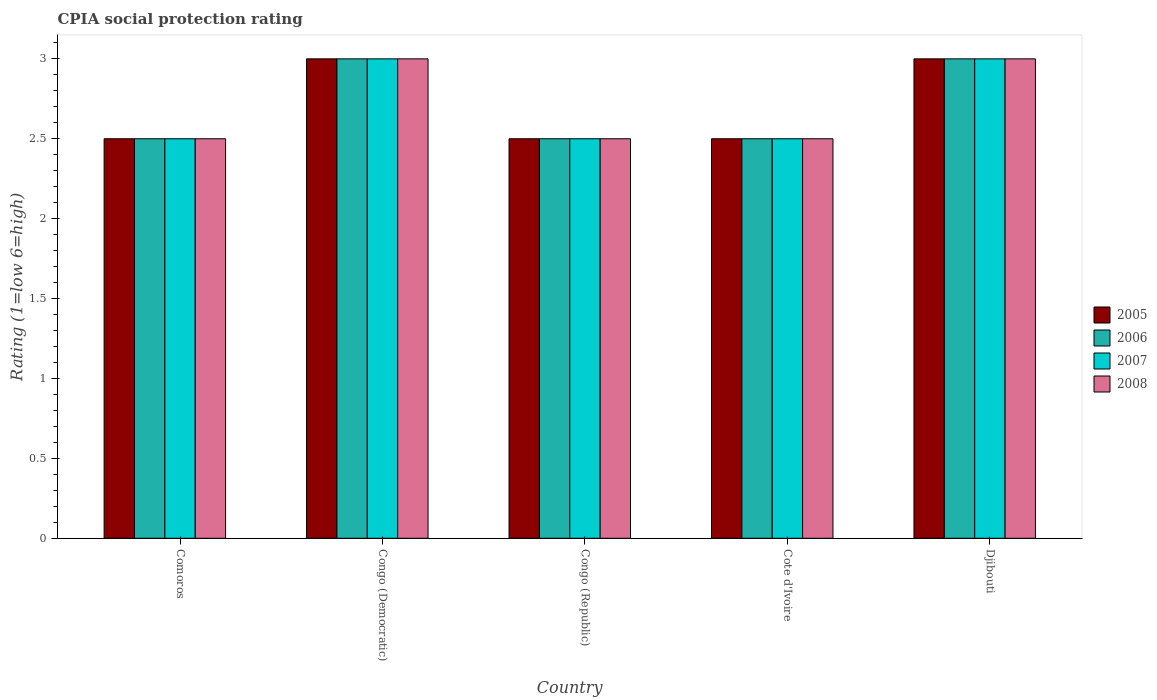How many different coloured bars are there?
Provide a short and direct response. 4. Are the number of bars per tick equal to the number of legend labels?
Make the answer very short. Yes. How many bars are there on the 5th tick from the right?
Provide a short and direct response. 4. What is the label of the 3rd group of bars from the left?
Your answer should be compact. Congo (Republic). In how many cases, is the number of bars for a given country not equal to the number of legend labels?
Your answer should be very brief. 0. In which country was the CPIA rating in 2007 maximum?
Keep it short and to the point. Congo (Democratic). In which country was the CPIA rating in 2008 minimum?
Give a very brief answer. Comoros. What is the difference between the CPIA rating in 2007 in Congo (Democratic) and that in Djibouti?
Give a very brief answer. 0. In how many countries, is the CPIA rating in 2005 greater than 0.4?
Give a very brief answer. 5. What is the ratio of the CPIA rating in 2007 in Comoros to that in Congo (Republic)?
Your answer should be compact. 1. What is the difference between the highest and the second highest CPIA rating in 2005?
Give a very brief answer. -0.5. What is the difference between the highest and the lowest CPIA rating in 2005?
Make the answer very short. 0.5. In how many countries, is the CPIA rating in 2005 greater than the average CPIA rating in 2005 taken over all countries?
Give a very brief answer. 2. What does the 2nd bar from the right in Djibouti represents?
Provide a short and direct response. 2007. Are all the bars in the graph horizontal?
Provide a short and direct response. No. What is the difference between two consecutive major ticks on the Y-axis?
Offer a very short reply. 0.5. Are the values on the major ticks of Y-axis written in scientific E-notation?
Provide a succinct answer. No. Does the graph contain grids?
Ensure brevity in your answer.  No. How many legend labels are there?
Keep it short and to the point. 4. How are the legend labels stacked?
Offer a very short reply. Vertical. What is the title of the graph?
Make the answer very short. CPIA social protection rating. Does "1972" appear as one of the legend labels in the graph?
Provide a short and direct response. No. What is the label or title of the X-axis?
Give a very brief answer. Country. What is the label or title of the Y-axis?
Provide a short and direct response. Rating (1=low 6=high). What is the Rating (1=low 6=high) in 2005 in Congo (Democratic)?
Give a very brief answer. 3. What is the Rating (1=low 6=high) of 2007 in Congo (Democratic)?
Your answer should be compact. 3. What is the Rating (1=low 6=high) in 2008 in Congo (Democratic)?
Provide a succinct answer. 3. What is the Rating (1=low 6=high) in 2007 in Congo (Republic)?
Offer a terse response. 2.5. What is the Rating (1=low 6=high) of 2008 in Congo (Republic)?
Keep it short and to the point. 2.5. What is the Rating (1=low 6=high) in 2006 in Cote d'Ivoire?
Your answer should be compact. 2.5. What is the Rating (1=low 6=high) in 2007 in Cote d'Ivoire?
Your response must be concise. 2.5. What is the Rating (1=low 6=high) of 2005 in Djibouti?
Keep it short and to the point. 3. What is the Rating (1=low 6=high) of 2007 in Djibouti?
Your answer should be compact. 3. What is the Rating (1=low 6=high) in 2008 in Djibouti?
Offer a very short reply. 3. Across all countries, what is the maximum Rating (1=low 6=high) in 2007?
Offer a very short reply. 3. Across all countries, what is the maximum Rating (1=low 6=high) of 2008?
Offer a terse response. 3. Across all countries, what is the minimum Rating (1=low 6=high) in 2005?
Provide a short and direct response. 2.5. What is the total Rating (1=low 6=high) in 2005 in the graph?
Provide a short and direct response. 13.5. What is the total Rating (1=low 6=high) of 2006 in the graph?
Ensure brevity in your answer.  13.5. What is the total Rating (1=low 6=high) of 2008 in the graph?
Give a very brief answer. 13.5. What is the difference between the Rating (1=low 6=high) of 2006 in Comoros and that in Congo (Democratic)?
Your answer should be very brief. -0.5. What is the difference between the Rating (1=low 6=high) of 2006 in Comoros and that in Congo (Republic)?
Keep it short and to the point. 0. What is the difference between the Rating (1=low 6=high) in 2005 in Comoros and that in Cote d'Ivoire?
Offer a very short reply. 0. What is the difference between the Rating (1=low 6=high) in 2007 in Comoros and that in Cote d'Ivoire?
Give a very brief answer. 0. What is the difference between the Rating (1=low 6=high) in 2008 in Comoros and that in Cote d'Ivoire?
Ensure brevity in your answer.  0. What is the difference between the Rating (1=low 6=high) of 2006 in Comoros and that in Djibouti?
Your answer should be very brief. -0.5. What is the difference between the Rating (1=low 6=high) of 2007 in Comoros and that in Djibouti?
Your answer should be compact. -0.5. What is the difference between the Rating (1=low 6=high) of 2005 in Congo (Democratic) and that in Cote d'Ivoire?
Provide a succinct answer. 0.5. What is the difference between the Rating (1=low 6=high) of 2007 in Congo (Democratic) and that in Cote d'Ivoire?
Keep it short and to the point. 0.5. What is the difference between the Rating (1=low 6=high) of 2005 in Congo (Democratic) and that in Djibouti?
Keep it short and to the point. 0. What is the difference between the Rating (1=low 6=high) in 2006 in Congo (Democratic) and that in Djibouti?
Provide a short and direct response. 0. What is the difference between the Rating (1=low 6=high) of 2008 in Congo (Democratic) and that in Djibouti?
Ensure brevity in your answer.  0. What is the difference between the Rating (1=low 6=high) of 2007 in Congo (Republic) and that in Cote d'Ivoire?
Give a very brief answer. 0. What is the difference between the Rating (1=low 6=high) in 2008 in Congo (Republic) and that in Cote d'Ivoire?
Provide a succinct answer. 0. What is the difference between the Rating (1=low 6=high) in 2006 in Congo (Republic) and that in Djibouti?
Your response must be concise. -0.5. What is the difference between the Rating (1=low 6=high) in 2005 in Cote d'Ivoire and that in Djibouti?
Provide a succinct answer. -0.5. What is the difference between the Rating (1=low 6=high) of 2007 in Cote d'Ivoire and that in Djibouti?
Offer a very short reply. -0.5. What is the difference between the Rating (1=low 6=high) in 2005 in Comoros and the Rating (1=low 6=high) in 2007 in Congo (Democratic)?
Offer a terse response. -0.5. What is the difference between the Rating (1=low 6=high) in 2006 in Comoros and the Rating (1=low 6=high) in 2008 in Congo (Democratic)?
Your answer should be very brief. -0.5. What is the difference between the Rating (1=low 6=high) of 2007 in Comoros and the Rating (1=low 6=high) of 2008 in Congo (Democratic)?
Provide a succinct answer. -0.5. What is the difference between the Rating (1=low 6=high) of 2005 in Comoros and the Rating (1=low 6=high) of 2007 in Cote d'Ivoire?
Provide a short and direct response. 0. What is the difference between the Rating (1=low 6=high) of 2005 in Comoros and the Rating (1=low 6=high) of 2008 in Cote d'Ivoire?
Keep it short and to the point. 0. What is the difference between the Rating (1=low 6=high) of 2006 in Comoros and the Rating (1=low 6=high) of 2008 in Cote d'Ivoire?
Ensure brevity in your answer.  0. What is the difference between the Rating (1=low 6=high) of 2005 in Comoros and the Rating (1=low 6=high) of 2007 in Djibouti?
Your answer should be very brief. -0.5. What is the difference between the Rating (1=low 6=high) of 2005 in Comoros and the Rating (1=low 6=high) of 2008 in Djibouti?
Your answer should be compact. -0.5. What is the difference between the Rating (1=low 6=high) in 2006 in Comoros and the Rating (1=low 6=high) in 2007 in Djibouti?
Offer a very short reply. -0.5. What is the difference between the Rating (1=low 6=high) in 2006 in Comoros and the Rating (1=low 6=high) in 2008 in Djibouti?
Offer a very short reply. -0.5. What is the difference between the Rating (1=low 6=high) in 2007 in Comoros and the Rating (1=low 6=high) in 2008 in Djibouti?
Your answer should be compact. -0.5. What is the difference between the Rating (1=low 6=high) of 2005 in Congo (Democratic) and the Rating (1=low 6=high) of 2007 in Congo (Republic)?
Ensure brevity in your answer.  0.5. What is the difference between the Rating (1=low 6=high) in 2005 in Congo (Democratic) and the Rating (1=low 6=high) in 2008 in Congo (Republic)?
Your answer should be very brief. 0.5. What is the difference between the Rating (1=low 6=high) in 2006 in Congo (Democratic) and the Rating (1=low 6=high) in 2007 in Congo (Republic)?
Your response must be concise. 0.5. What is the difference between the Rating (1=low 6=high) in 2007 in Congo (Democratic) and the Rating (1=low 6=high) in 2008 in Congo (Republic)?
Provide a succinct answer. 0.5. What is the difference between the Rating (1=low 6=high) in 2005 in Congo (Democratic) and the Rating (1=low 6=high) in 2007 in Cote d'Ivoire?
Give a very brief answer. 0.5. What is the difference between the Rating (1=low 6=high) of 2005 in Congo (Democratic) and the Rating (1=low 6=high) of 2008 in Cote d'Ivoire?
Your response must be concise. 0.5. What is the difference between the Rating (1=low 6=high) of 2007 in Congo (Democratic) and the Rating (1=low 6=high) of 2008 in Cote d'Ivoire?
Make the answer very short. 0.5. What is the difference between the Rating (1=low 6=high) of 2005 in Congo (Democratic) and the Rating (1=low 6=high) of 2006 in Djibouti?
Offer a very short reply. 0. What is the difference between the Rating (1=low 6=high) of 2005 in Congo (Democratic) and the Rating (1=low 6=high) of 2008 in Djibouti?
Ensure brevity in your answer.  0. What is the difference between the Rating (1=low 6=high) of 2006 in Congo (Democratic) and the Rating (1=low 6=high) of 2007 in Djibouti?
Offer a very short reply. 0. What is the difference between the Rating (1=low 6=high) of 2007 in Congo (Democratic) and the Rating (1=low 6=high) of 2008 in Djibouti?
Your answer should be compact. 0. What is the difference between the Rating (1=low 6=high) of 2005 in Congo (Republic) and the Rating (1=low 6=high) of 2006 in Cote d'Ivoire?
Provide a short and direct response. 0. What is the difference between the Rating (1=low 6=high) in 2005 in Congo (Republic) and the Rating (1=low 6=high) in 2007 in Cote d'Ivoire?
Your response must be concise. 0. What is the difference between the Rating (1=low 6=high) in 2007 in Congo (Republic) and the Rating (1=low 6=high) in 2008 in Cote d'Ivoire?
Your answer should be very brief. 0. What is the difference between the Rating (1=low 6=high) in 2005 in Congo (Republic) and the Rating (1=low 6=high) in 2008 in Djibouti?
Provide a short and direct response. -0.5. What is the difference between the Rating (1=low 6=high) of 2006 in Congo (Republic) and the Rating (1=low 6=high) of 2008 in Djibouti?
Provide a succinct answer. -0.5. What is the difference between the Rating (1=low 6=high) of 2005 in Cote d'Ivoire and the Rating (1=low 6=high) of 2006 in Djibouti?
Keep it short and to the point. -0.5. What is the difference between the Rating (1=low 6=high) in 2005 in Cote d'Ivoire and the Rating (1=low 6=high) in 2007 in Djibouti?
Give a very brief answer. -0.5. What is the difference between the Rating (1=low 6=high) of 2006 in Cote d'Ivoire and the Rating (1=low 6=high) of 2007 in Djibouti?
Give a very brief answer. -0.5. What is the difference between the Rating (1=low 6=high) of 2007 in Cote d'Ivoire and the Rating (1=low 6=high) of 2008 in Djibouti?
Keep it short and to the point. -0.5. What is the average Rating (1=low 6=high) in 2005 per country?
Offer a very short reply. 2.7. What is the average Rating (1=low 6=high) in 2007 per country?
Make the answer very short. 2.7. What is the difference between the Rating (1=low 6=high) in 2005 and Rating (1=low 6=high) in 2006 in Comoros?
Offer a very short reply. 0. What is the difference between the Rating (1=low 6=high) of 2005 and Rating (1=low 6=high) of 2007 in Comoros?
Offer a terse response. 0. What is the difference between the Rating (1=low 6=high) of 2006 and Rating (1=low 6=high) of 2007 in Comoros?
Provide a succinct answer. 0. What is the difference between the Rating (1=low 6=high) in 2006 and Rating (1=low 6=high) in 2008 in Comoros?
Provide a succinct answer. 0. What is the difference between the Rating (1=low 6=high) of 2005 and Rating (1=low 6=high) of 2008 in Congo (Democratic)?
Provide a short and direct response. 0. What is the difference between the Rating (1=low 6=high) in 2007 and Rating (1=low 6=high) in 2008 in Congo (Democratic)?
Your answer should be very brief. 0. What is the difference between the Rating (1=low 6=high) in 2005 and Rating (1=low 6=high) in 2007 in Cote d'Ivoire?
Offer a terse response. 0. What is the difference between the Rating (1=low 6=high) of 2005 and Rating (1=low 6=high) of 2008 in Cote d'Ivoire?
Offer a very short reply. 0. What is the difference between the Rating (1=low 6=high) in 2007 and Rating (1=low 6=high) in 2008 in Cote d'Ivoire?
Provide a short and direct response. 0. What is the difference between the Rating (1=low 6=high) of 2005 and Rating (1=low 6=high) of 2006 in Djibouti?
Your answer should be very brief. 0. What is the difference between the Rating (1=low 6=high) of 2006 and Rating (1=low 6=high) of 2007 in Djibouti?
Your response must be concise. 0. What is the difference between the Rating (1=low 6=high) of 2007 and Rating (1=low 6=high) of 2008 in Djibouti?
Your answer should be compact. 0. What is the ratio of the Rating (1=low 6=high) of 2005 in Comoros to that in Congo (Democratic)?
Provide a short and direct response. 0.83. What is the ratio of the Rating (1=low 6=high) of 2007 in Comoros to that in Congo (Democratic)?
Provide a succinct answer. 0.83. What is the ratio of the Rating (1=low 6=high) in 2005 in Comoros to that in Congo (Republic)?
Give a very brief answer. 1. What is the ratio of the Rating (1=low 6=high) of 2007 in Comoros to that in Congo (Republic)?
Provide a succinct answer. 1. What is the ratio of the Rating (1=low 6=high) in 2006 in Comoros to that in Cote d'Ivoire?
Offer a very short reply. 1. What is the ratio of the Rating (1=low 6=high) of 2007 in Comoros to that in Cote d'Ivoire?
Your answer should be very brief. 1. What is the ratio of the Rating (1=low 6=high) in 2008 in Comoros to that in Cote d'Ivoire?
Make the answer very short. 1. What is the ratio of the Rating (1=low 6=high) in 2007 in Comoros to that in Djibouti?
Give a very brief answer. 0.83. What is the ratio of the Rating (1=low 6=high) in 2005 in Congo (Democratic) to that in Cote d'Ivoire?
Your answer should be compact. 1.2. What is the ratio of the Rating (1=low 6=high) in 2006 in Congo (Democratic) to that in Cote d'Ivoire?
Offer a very short reply. 1.2. What is the ratio of the Rating (1=low 6=high) in 2007 in Congo (Democratic) to that in Cote d'Ivoire?
Your answer should be very brief. 1.2. What is the ratio of the Rating (1=low 6=high) of 2006 in Congo (Democratic) to that in Djibouti?
Offer a terse response. 1. What is the ratio of the Rating (1=low 6=high) of 2007 in Congo (Democratic) to that in Djibouti?
Provide a succinct answer. 1. What is the ratio of the Rating (1=low 6=high) in 2008 in Congo (Democratic) to that in Djibouti?
Provide a succinct answer. 1. What is the ratio of the Rating (1=low 6=high) in 2005 in Congo (Republic) to that in Cote d'Ivoire?
Provide a succinct answer. 1. What is the ratio of the Rating (1=low 6=high) of 2006 in Congo (Republic) to that in Cote d'Ivoire?
Offer a very short reply. 1. What is the ratio of the Rating (1=low 6=high) in 2007 in Congo (Republic) to that in Cote d'Ivoire?
Offer a very short reply. 1. What is the ratio of the Rating (1=low 6=high) of 2008 in Congo (Republic) to that in Cote d'Ivoire?
Keep it short and to the point. 1. What is the ratio of the Rating (1=low 6=high) in 2006 in Congo (Republic) to that in Djibouti?
Give a very brief answer. 0.83. What is the ratio of the Rating (1=low 6=high) in 2005 in Cote d'Ivoire to that in Djibouti?
Keep it short and to the point. 0.83. What is the ratio of the Rating (1=low 6=high) of 2008 in Cote d'Ivoire to that in Djibouti?
Offer a terse response. 0.83. What is the difference between the highest and the second highest Rating (1=low 6=high) in 2005?
Provide a succinct answer. 0. What is the difference between the highest and the second highest Rating (1=low 6=high) in 2006?
Provide a succinct answer. 0. What is the difference between the highest and the second highest Rating (1=low 6=high) of 2008?
Provide a short and direct response. 0. What is the difference between the highest and the lowest Rating (1=low 6=high) of 2005?
Provide a succinct answer. 0.5. What is the difference between the highest and the lowest Rating (1=low 6=high) in 2006?
Your response must be concise. 0.5. What is the difference between the highest and the lowest Rating (1=low 6=high) of 2007?
Keep it short and to the point. 0.5. What is the difference between the highest and the lowest Rating (1=low 6=high) in 2008?
Provide a short and direct response. 0.5. 